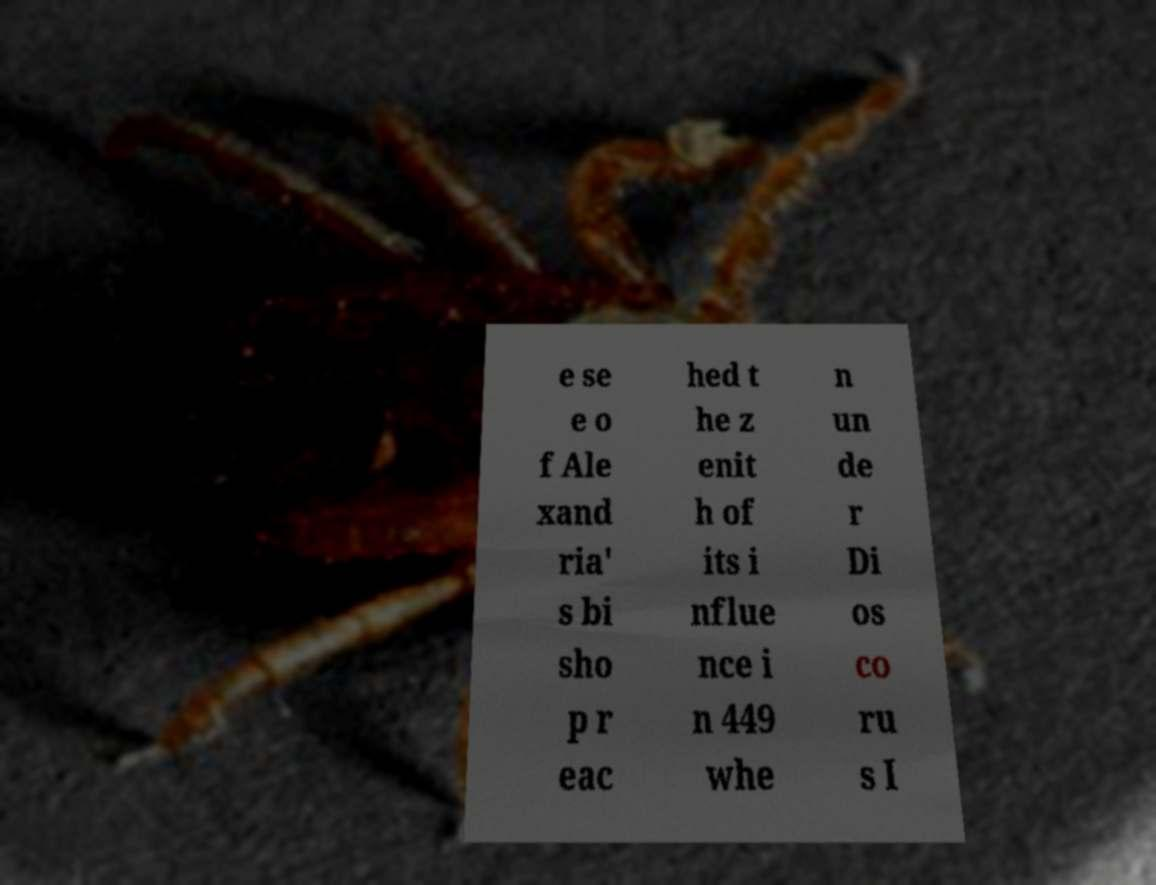Please identify and transcribe the text found in this image. e se e o f Ale xand ria' s bi sho p r eac hed t he z enit h of its i nflue nce i n 449 whe n un de r Di os co ru s I 